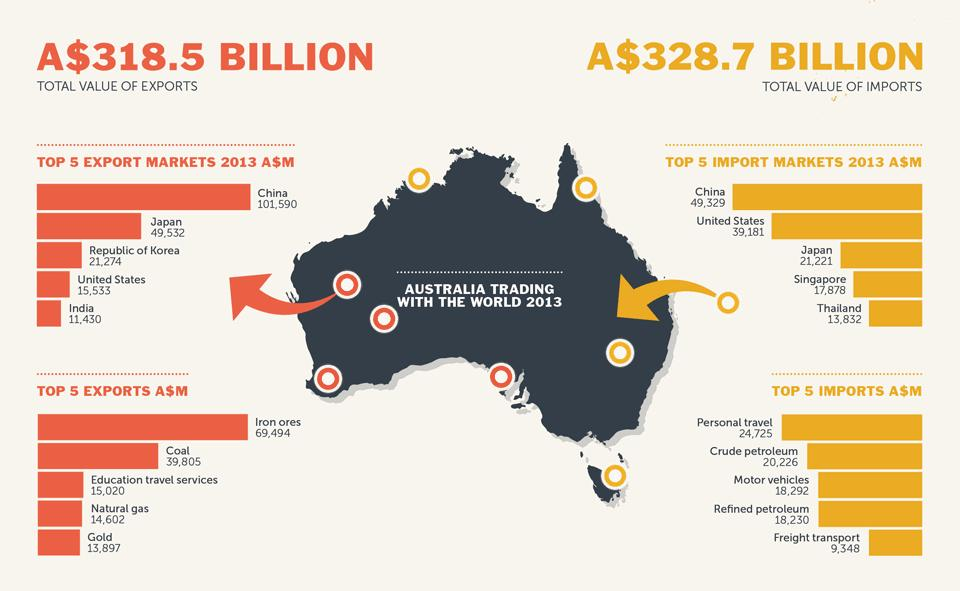Give some essential details in this illustration. The difference in the value of exports to the United States and India from Australia is 4,103. Coal is the second most exported item from Australia. Australia exports the most gold among all its metal exports. The value of imports from China to Australia in 2021 was approximately 49,329. Australia imports the second largest amount of crude petroleum, followed by other products. 